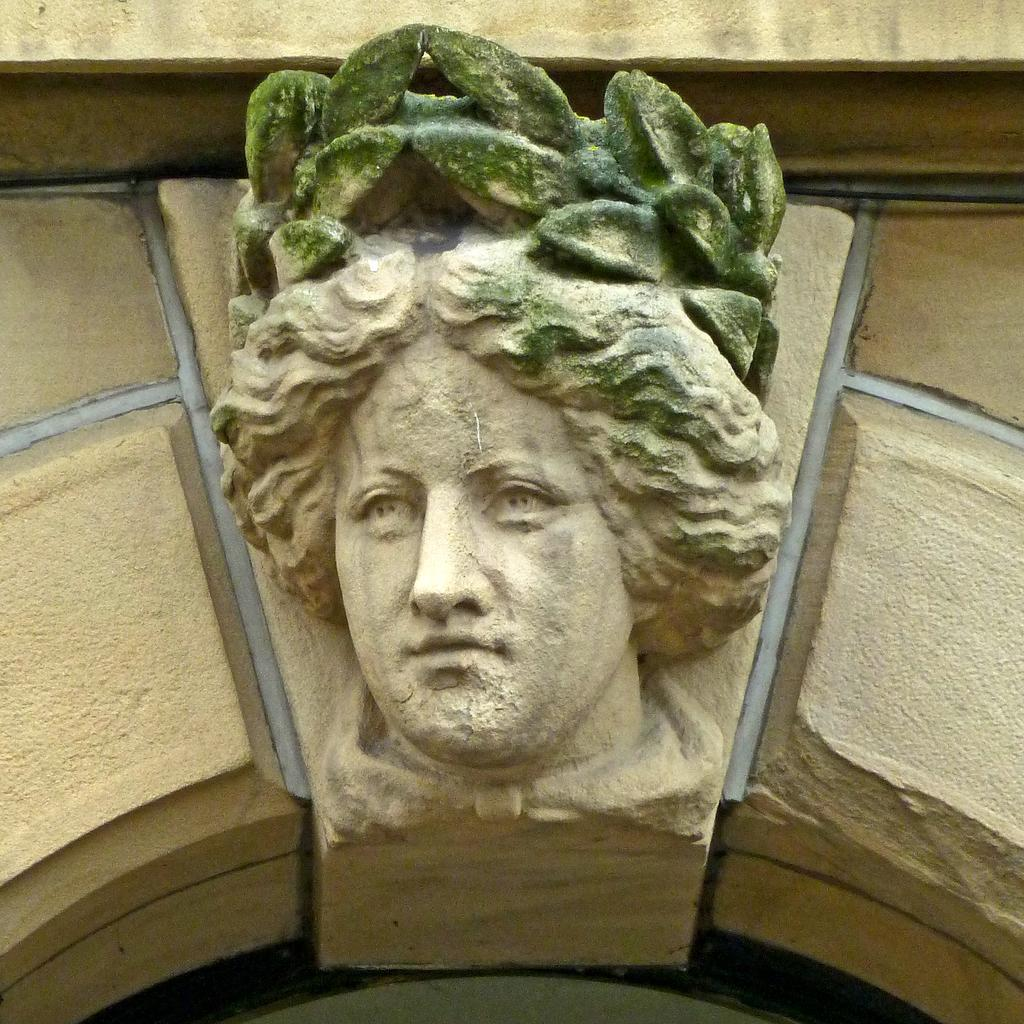What is the main subject of the image? There is a statue in the image. Can you describe the statue? The statue is of a lady. Where is the statue located in the image? The statue is in the center of the image. What type of harmony is being played by the lady statue in the image? There is no indication in the image that the lady statue is playing any type of harmony, as statues are not capable of playing music. 